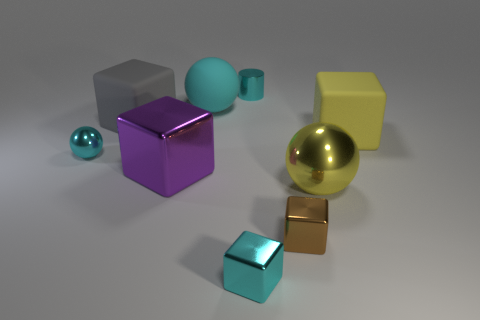There is a big shiny thing on the right side of the shiny object that is behind the tiny shiny thing that is on the left side of the gray object; what is its shape?
Provide a short and direct response. Sphere. What color is the object that is both on the right side of the cyan cylinder and behind the purple shiny object?
Offer a terse response. Yellow. The large metal thing that is left of the yellow sphere has what shape?
Provide a succinct answer. Cube. There is a yellow thing that is made of the same material as the tiny cylinder; what is its shape?
Offer a terse response. Sphere. How many metallic things are either cyan things or brown objects?
Offer a very short reply. 4. There is a big purple metal object to the left of the small shiny thing behind the large yellow matte object; what number of balls are on the right side of it?
Make the answer very short. 2. There is a metal ball that is to the left of the tiny cyan cube; is it the same size as the cyan metallic object that is behind the large yellow rubber cube?
Ensure brevity in your answer.  Yes. There is a big yellow thing that is the same shape as the large purple metal thing; what is it made of?
Make the answer very short. Rubber. How many large objects are either metallic balls or cylinders?
Keep it short and to the point. 1. What material is the small cylinder?
Ensure brevity in your answer.  Metal. 